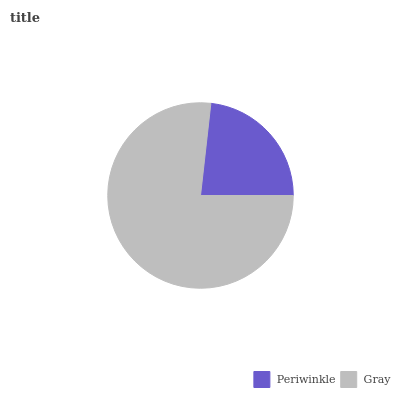Is Periwinkle the minimum?
Answer yes or no. Yes. Is Gray the maximum?
Answer yes or no. Yes. Is Gray the minimum?
Answer yes or no. No. Is Gray greater than Periwinkle?
Answer yes or no. Yes. Is Periwinkle less than Gray?
Answer yes or no. Yes. Is Periwinkle greater than Gray?
Answer yes or no. No. Is Gray less than Periwinkle?
Answer yes or no. No. Is Gray the high median?
Answer yes or no. Yes. Is Periwinkle the low median?
Answer yes or no. Yes. Is Periwinkle the high median?
Answer yes or no. No. Is Gray the low median?
Answer yes or no. No. 